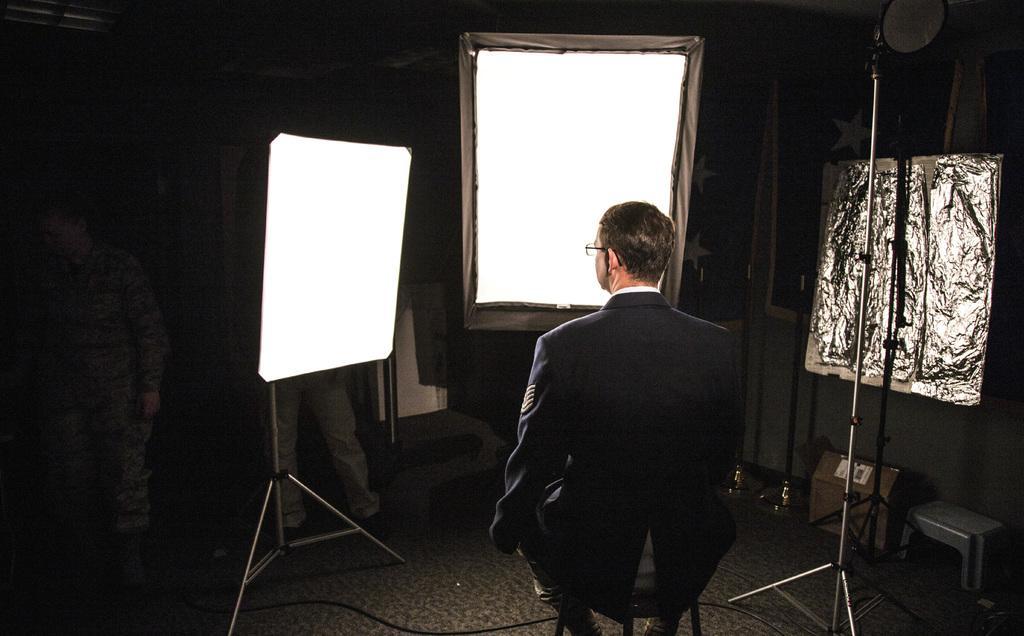Please provide a concise description of this image. In this image we can see a person wearing black color suit sitting on stool and in the background of the image there are some persons wearing camouflage dress, we can see some screens which are in white color and there is a wall. 